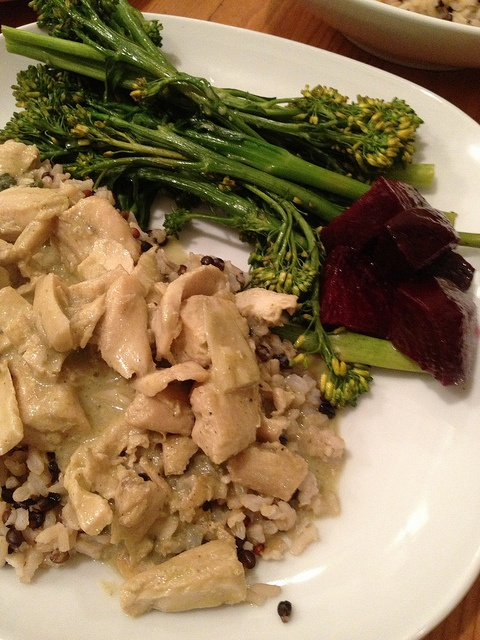Describe the objects in this image and their specific colors. I can see dining table in black, beige, olive, and tan tones, bowl in maroon, olive, black, and tan tones, and broccoli in maroon, darkgreen, black, and olive tones in this image. 